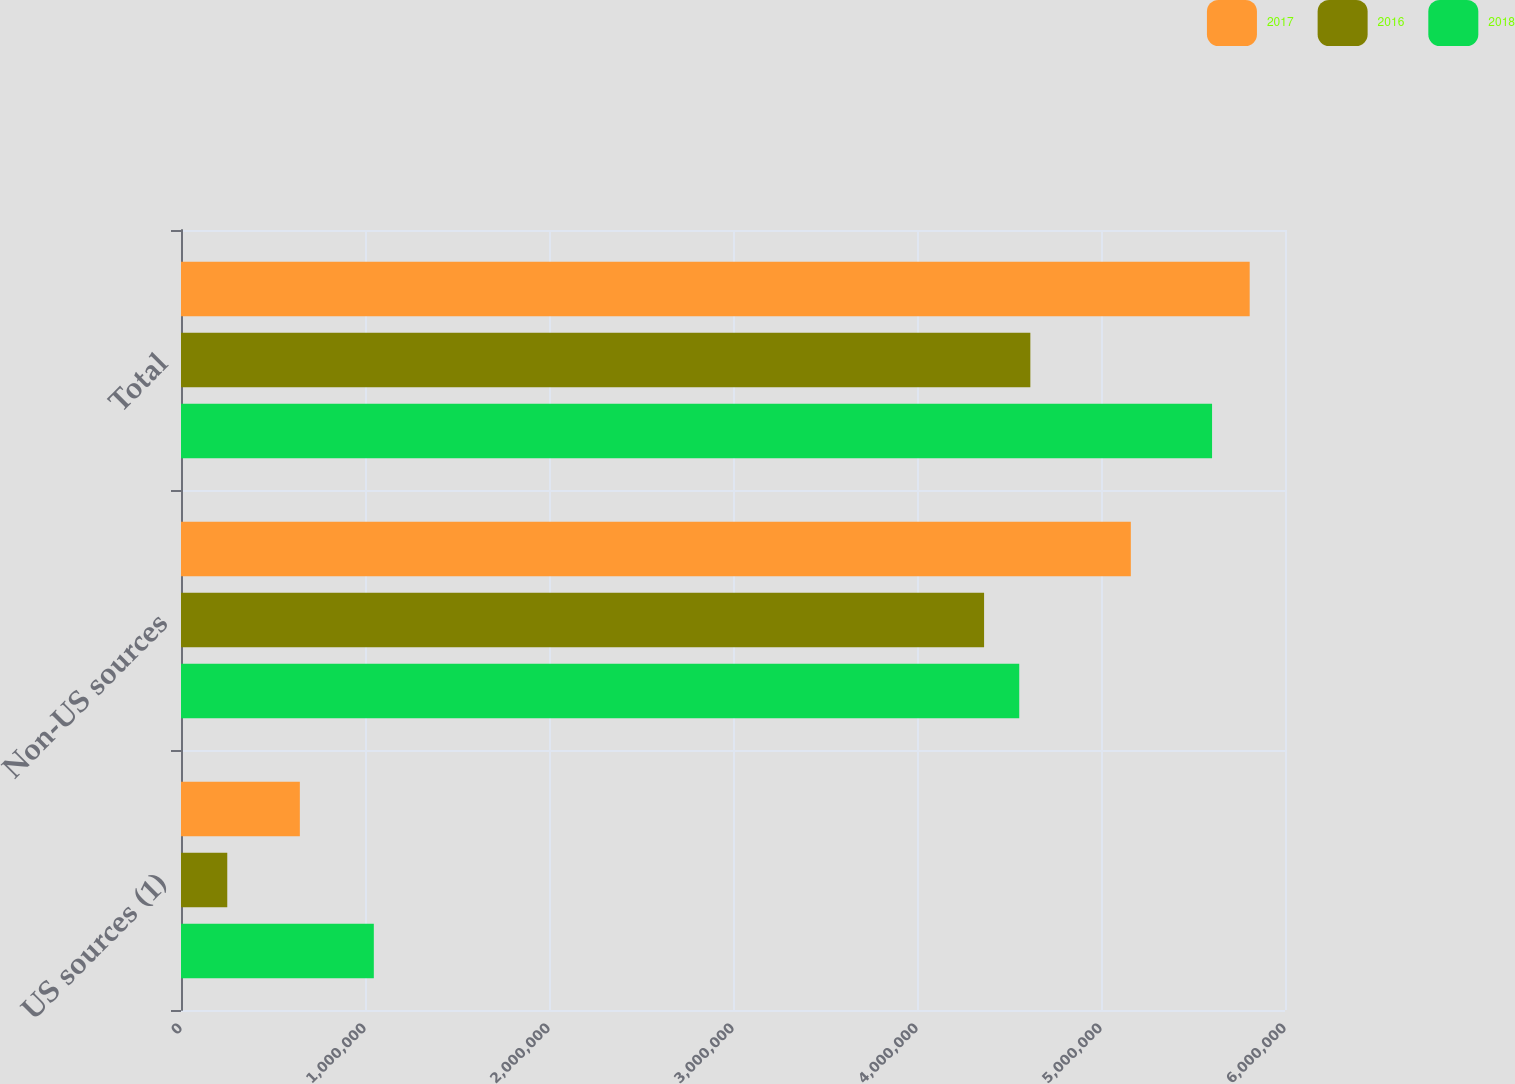<chart> <loc_0><loc_0><loc_500><loc_500><stacked_bar_chart><ecel><fcel>US sources (1)<fcel>Non-US sources<fcel>Total<nl><fcel>2017<fcel>645943<fcel>5.16215e+06<fcel>5.80809e+06<nl><fcel>2016<fcel>251456<fcel>4.36458e+06<fcel>4.61603e+06<nl><fcel>2018<fcel>1.04791e+06<fcel>4.55566e+06<fcel>5.60357e+06<nl></chart> 